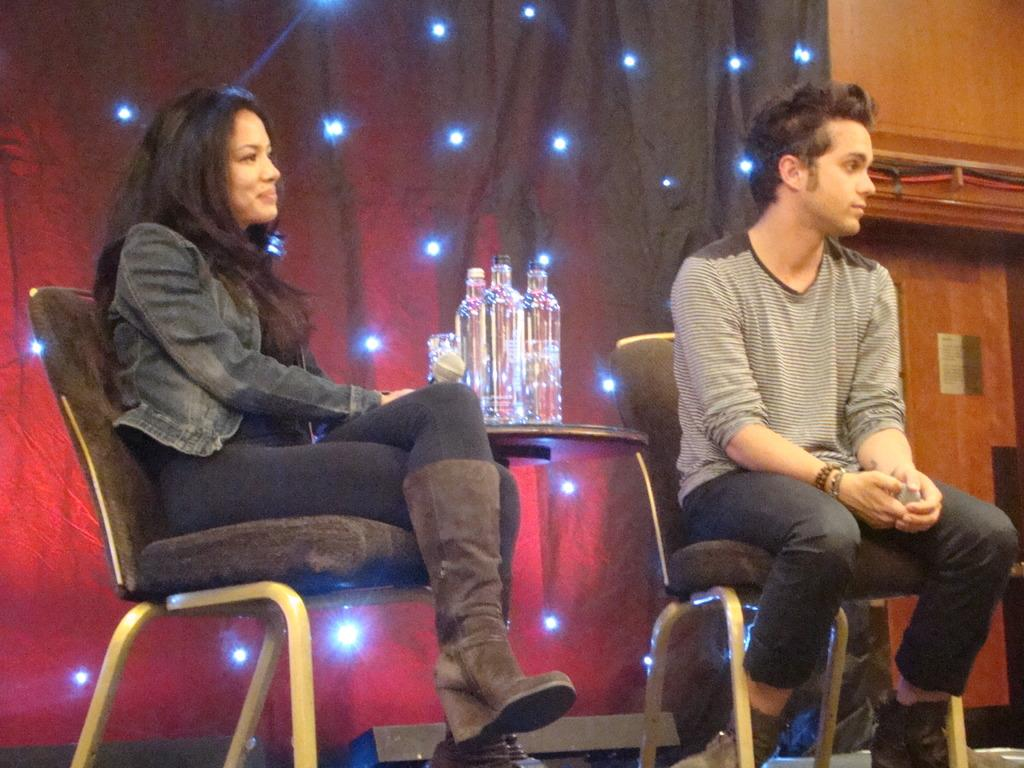How many people are sitting in the image? There are two persons sitting on chairs in the image. What is present between the two persons? There is a table in the image. What can be seen on the table? There are bottles on the table. What can be observed in the background of the image? There are focusing lights and a curtain in the background. What type of locket is hanging from the curtain in the image? There is no locket present in the image; only focusing lights and a curtain can be observed in the background. 